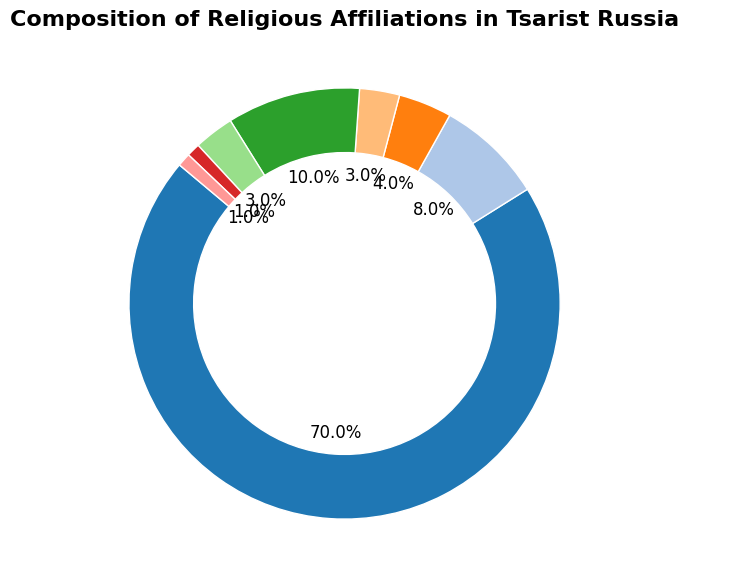Which religious group has the highest percentage? Each segment of the pie chart corresponds to a religious group, and the size of each segment represents the percentage of the population. The largest segment is for Eastern Orthodox.
Answer: Eastern Orthodox What is the combined percentage of Muslim and Jewish populations? To find the combined percentage, add the percentages of the Muslim and Jewish populations: 10% and 3%, respectively.
Answer: 13% How does the percentage of Roman Catholics compare to that of Protestants (Lutherans)? Compare the slices for Roman Catholics and Protestants (Lutherans). Roman Catholics have 4%, while Protestants have 3%.
Answer: Roman Catholics have a higher percentage Which two religious groups have the smallest percentages? Identify the two smallest segments in the pie chart, which represent the Buddhist and Armenian Apostolic groups, each with 1%.
Answer: Buddhist and Armenian Apostolic What is the percentage difference between Eastern Orthodox and Russian Orthodox Old Believers? Subtract the percentage of Russian Orthodox Old Believers from Eastern Orthodox: 70% - 8% = 62%.
Answer: 62% How many religions have a percentage higher than the Jewish population? Identify segments greater than 3% (Jewish): Eastern Orthodox (70%), Russian Orthodox Old Believers (8%), Roman Catholic (4%), and Muslim (10%)—four groups in total.
Answer: 4 religions What fraction of the total does the Protestant (Lutheran) population represent? The Protestant (Lutheran) percentage is 3%. Convert this percentage into a fraction: 3/100, which simplifies to 3%.
Answer: 3% If you combine the percentages of all groups except Eastern Orthodox, do they surpass 30%? Adding the percentages of all groups except Eastern Orthodox: 8% + 4% + 3% + 10% + 3% + 1% + 1% = 30%. They match rather than surpass 30%.
Answer: No Which religious groups collectively make up exactly half of the total population? Adding percentages to reach 50%: the Eastern Orthodox (70%) alone surpasses half. Thus, there isn't a combination of groups that collectively makes up exactly 50%.
Answer: None 